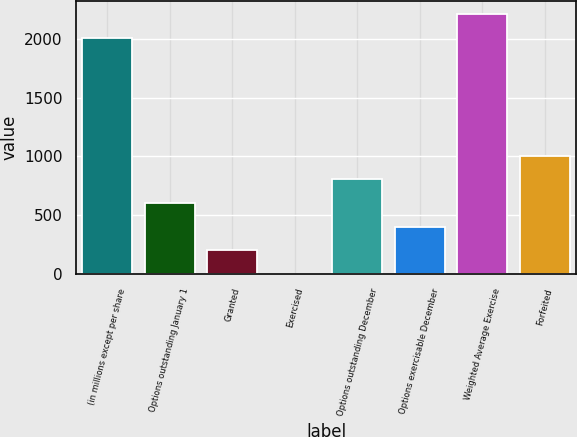Convert chart to OTSL. <chart><loc_0><loc_0><loc_500><loc_500><bar_chart><fcel>(in millions except per share<fcel>Options outstanding January 1<fcel>Granted<fcel>Exercised<fcel>Options outstanding December<fcel>Options exercisable December<fcel>Weighted Average Exercise<fcel>Forfeited<nl><fcel>2010<fcel>603.21<fcel>201.27<fcel>0.3<fcel>804.18<fcel>402.24<fcel>2210.97<fcel>1005.15<nl></chart> 